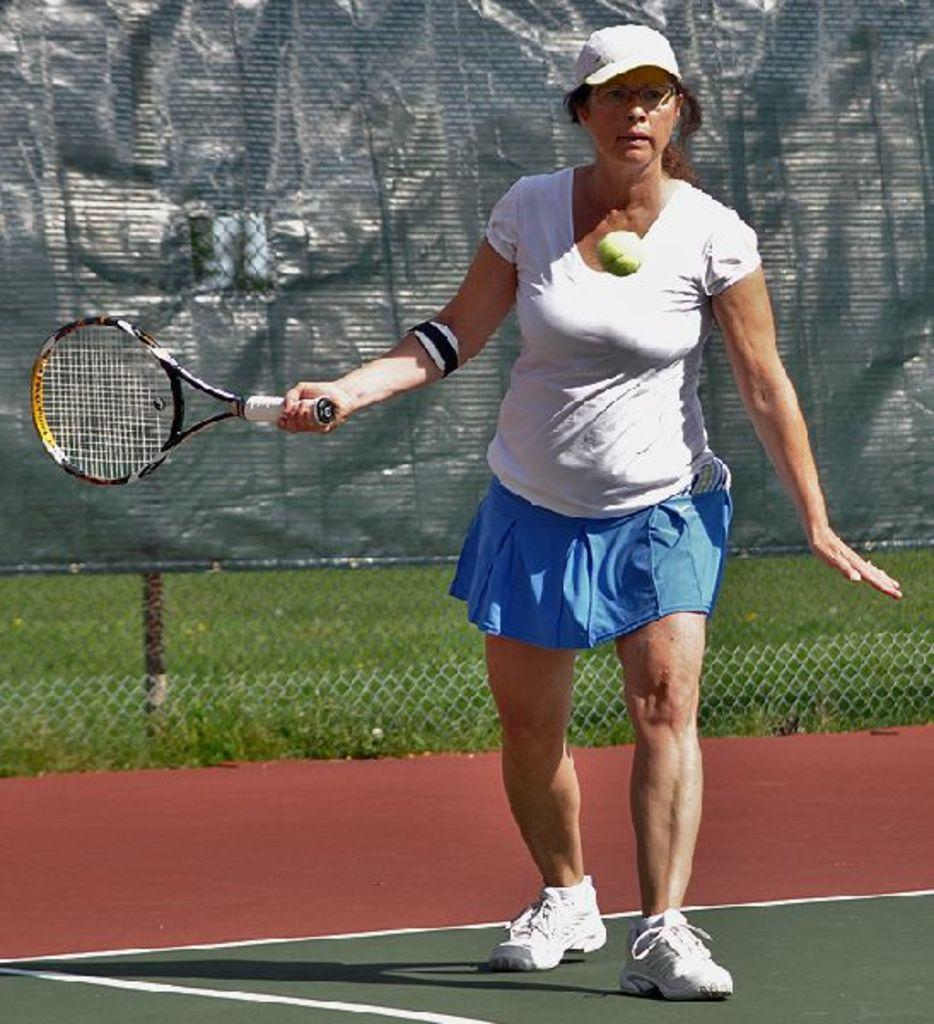What is the woman in the image holding? The woman is holding a tennis racket. What other tennis-related item can be seen in the image? There is a tennis ball in the image. What activity might the woman be engaged in, based on the items she is holding? The woman may be playing tennis. What can be seen in the background of the image? There is a black sheet and some fencing visible in the background of the image. What type of cherry is being served on a plate in the image? There is no cherry or plate present in the image. How comfortable is the woman's outfit while playing tennis in the image? The image does not provide enough information to determine the comfort level of the woman's outfit. 